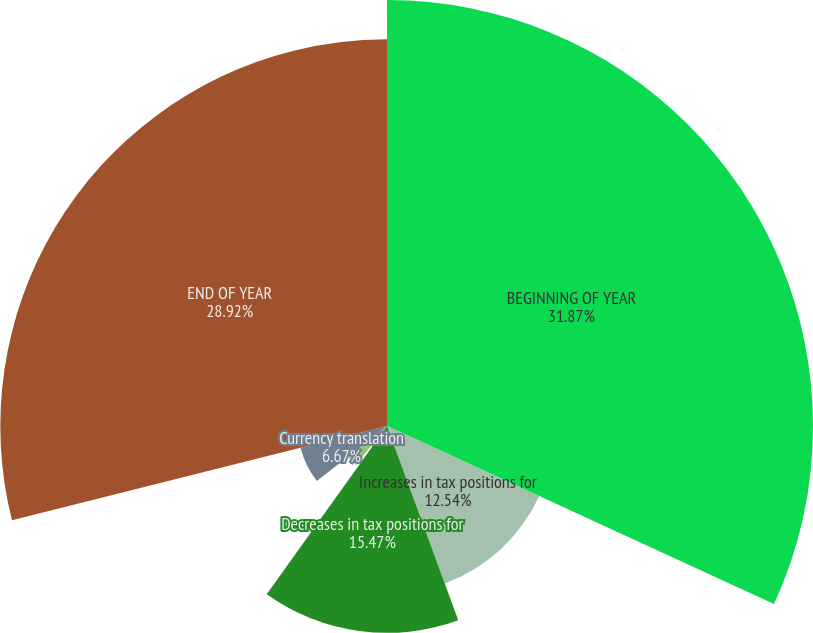Convert chart. <chart><loc_0><loc_0><loc_500><loc_500><pie_chart><fcel>BEGINNING OF YEAR<fcel>Increases in tax positions for<fcel>Decreases in tax positions for<fcel>Settlements with taxing<fcel>Lapse in statute of<fcel>Currency translation<fcel>END OF YEAR<nl><fcel>31.86%<fcel>12.54%<fcel>15.47%<fcel>0.8%<fcel>3.73%<fcel>6.67%<fcel>28.92%<nl></chart> 